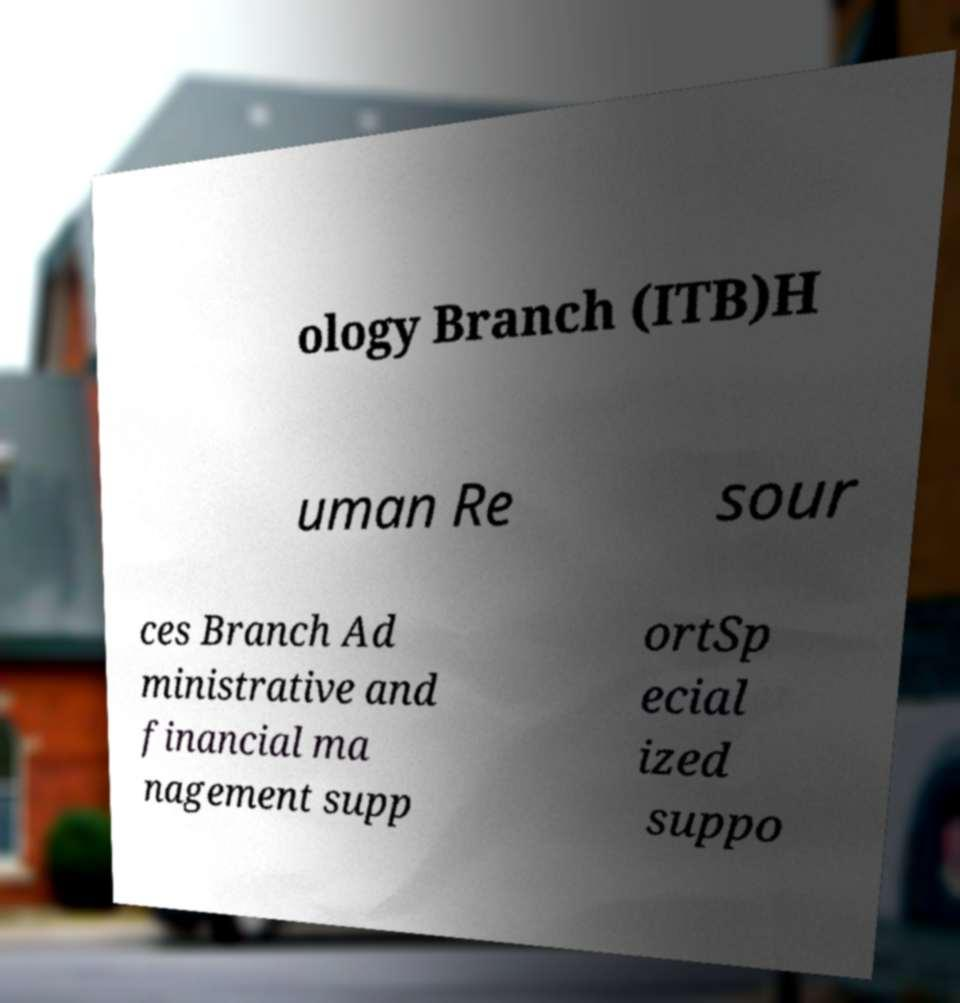Please identify and transcribe the text found in this image. ology Branch (ITB)H uman Re sour ces Branch Ad ministrative and financial ma nagement supp ortSp ecial ized suppo 